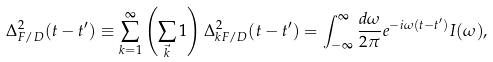Convert formula to latex. <formula><loc_0><loc_0><loc_500><loc_500>\Delta _ { F / D } ^ { 2 } ( t - t ^ { \prime } ) \equiv \sum _ { k = 1 } ^ { \infty } \left ( \sum _ { \vec { k } } 1 \right ) \Delta _ { k F / D } ^ { 2 } ( t - t ^ { \prime } ) = \int _ { - \infty } ^ { \infty } { \frac { d \omega } { 2 \pi } } e ^ { - i \omega ( t - t ^ { \prime } ) } I ( \omega ) ,</formula> 